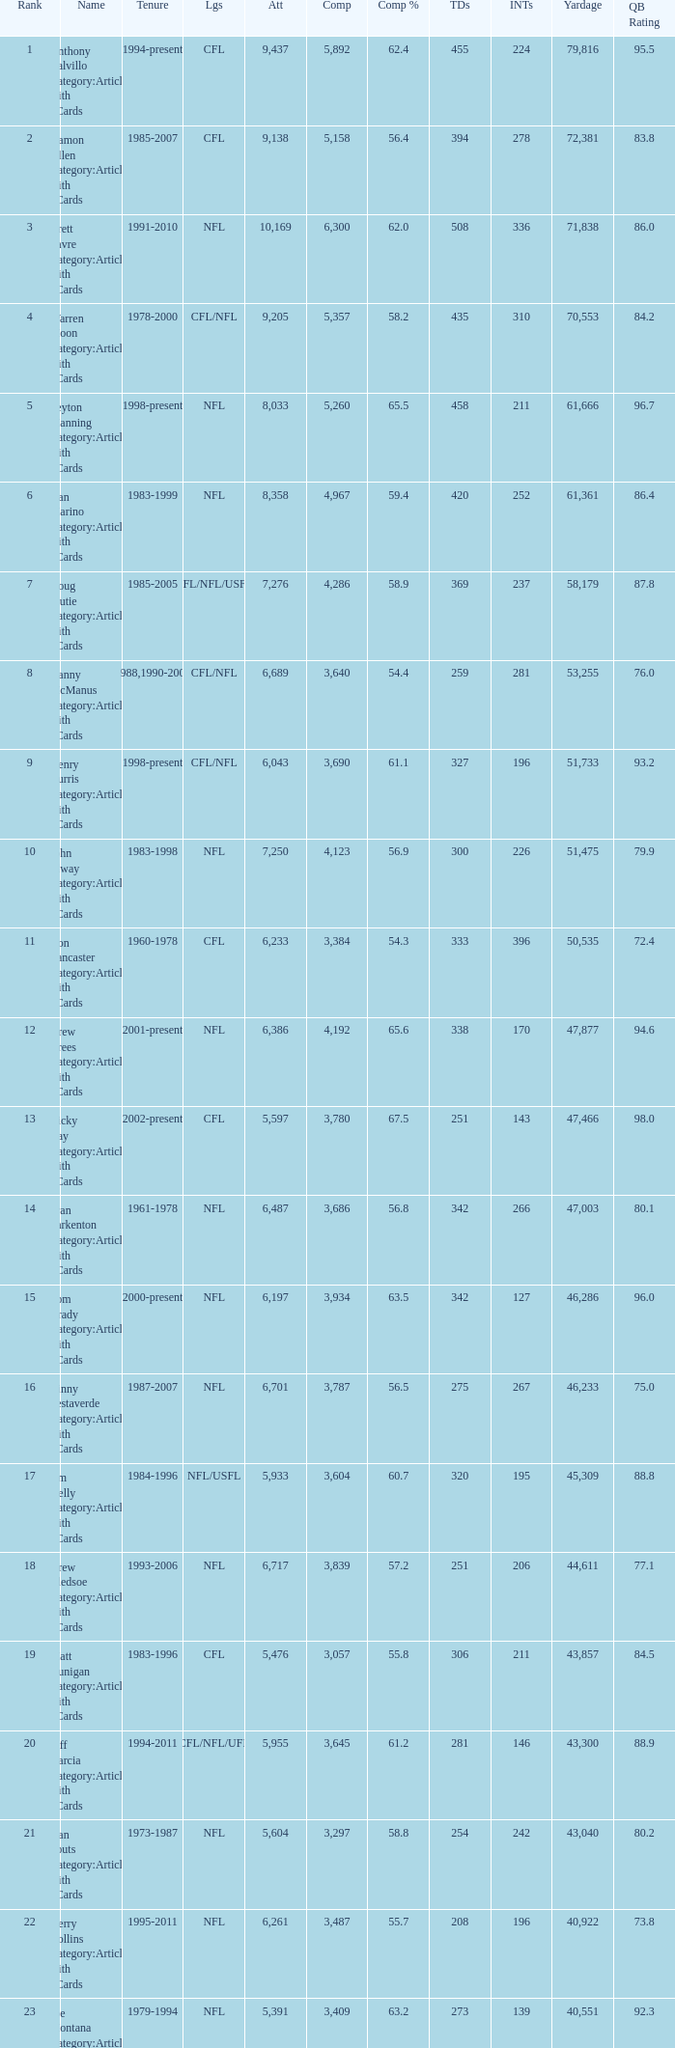What is the comp percentage when there are less than 44,611 in yardage, more than 254 touchdowns, and rank larger than 24? 54.6. 